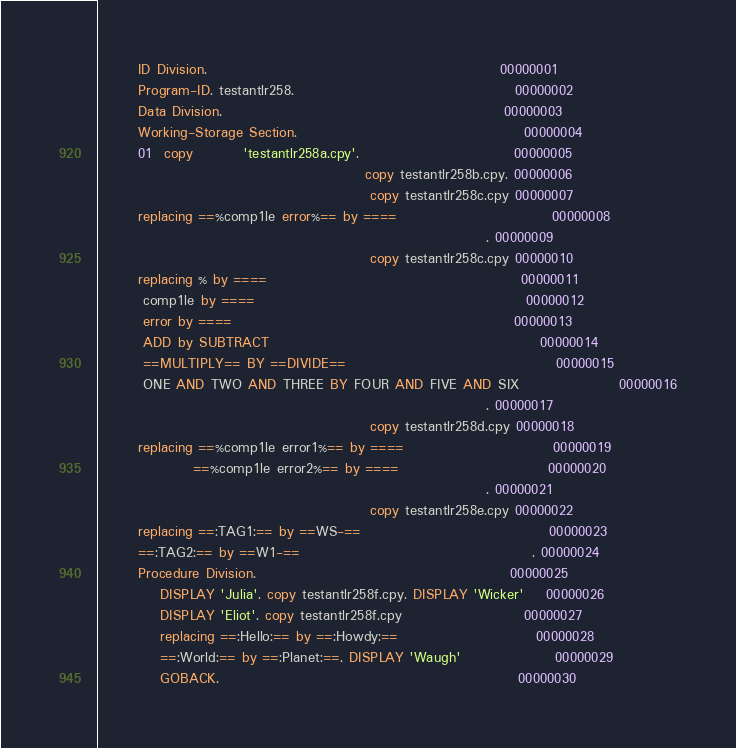<code> <loc_0><loc_0><loc_500><loc_500><_COBOL_>       ID Division.                                                     00000001
       Program-ID. testantlr258.                                        00000002
       Data Division.                                                   00000003
       Working-Storage Section.                                         00000004
       01  copy         'testantlr258a.cpy'.                            00000005
                                                copy testantlr258b.cpy. 00000006
                                                 copy testantlr258c.cpy 00000007
       replacing ==%comp1le error%== by ====                            00000008
                                                                      . 00000009
                                                 copy testantlr258c.cpy 00000010
       replacing % by ====                                              00000011
        comp1le by ====                                                 00000012
        error by ====                                                   00000013
        ADD by SUBTRACT                                                 00000014
        ==MULTIPLY== BY ==DIVIDE==                                      00000015
        ONE AND TWO AND THREE BY FOUR AND FIVE AND SIX                  00000016
                                                                      . 00000017
                                                 copy testantlr258d.cpy 00000018
       replacing ==%comp1le error1%== by ====                           00000019
                 ==%comp1le error2%== by ====                           00000020
                                                                      . 00000021
                                                 copy testantlr258e.cpy 00000022
       replacing ==:TAG1:== by ==WS-==                                  00000023
       ==:TAG2:== by ==W1-==                                          . 00000024
       Procedure Division.                                              00000025
           DISPLAY 'Julia'. copy testantlr258f.cpy. DISPLAY 'Wicker'    00000026
           DISPLAY 'Eliot'. copy testantlr258f.cpy                      00000027
           replacing ==:Hello:== by ==:Howdy:==                         00000028
           ==:World:== by ==:Planet:==. DISPLAY 'Waugh'                 00000029
           GOBACK.                                                      00000030
</code> 